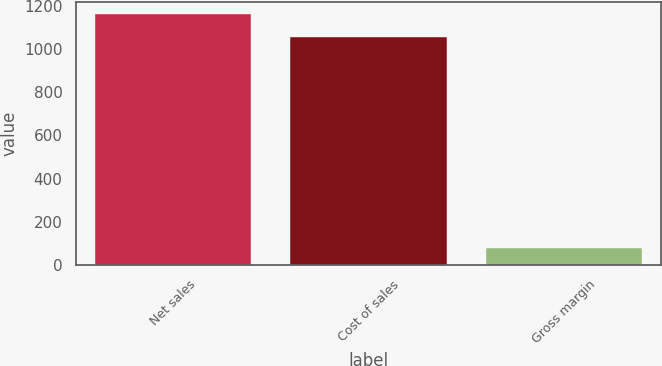<chart> <loc_0><loc_0><loc_500><loc_500><bar_chart><fcel>Net sales<fcel>Cost of sales<fcel>Gross margin<nl><fcel>1160.5<fcel>1055<fcel>79<nl></chart> 